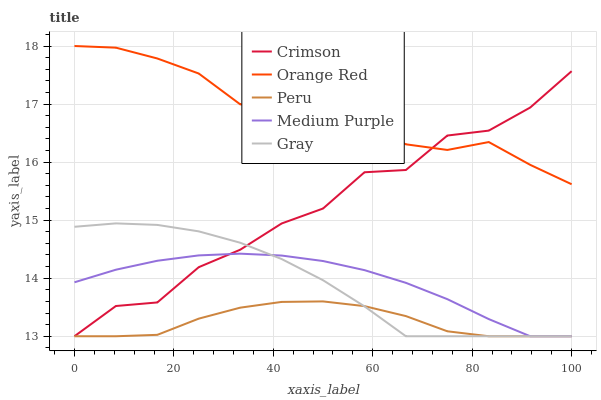Does Peru have the minimum area under the curve?
Answer yes or no. Yes. Does Orange Red have the maximum area under the curve?
Answer yes or no. Yes. Does Medium Purple have the minimum area under the curve?
Answer yes or no. No. Does Medium Purple have the maximum area under the curve?
Answer yes or no. No. Is Medium Purple the smoothest?
Answer yes or no. Yes. Is Crimson the roughest?
Answer yes or no. Yes. Is Orange Red the smoothest?
Answer yes or no. No. Is Orange Red the roughest?
Answer yes or no. No. Does Crimson have the lowest value?
Answer yes or no. Yes. Does Orange Red have the lowest value?
Answer yes or no. No. Does Orange Red have the highest value?
Answer yes or no. Yes. Does Medium Purple have the highest value?
Answer yes or no. No. Is Peru less than Orange Red?
Answer yes or no. Yes. Is Orange Red greater than Medium Purple?
Answer yes or no. Yes. Does Crimson intersect Peru?
Answer yes or no. Yes. Is Crimson less than Peru?
Answer yes or no. No. Is Crimson greater than Peru?
Answer yes or no. No. Does Peru intersect Orange Red?
Answer yes or no. No. 